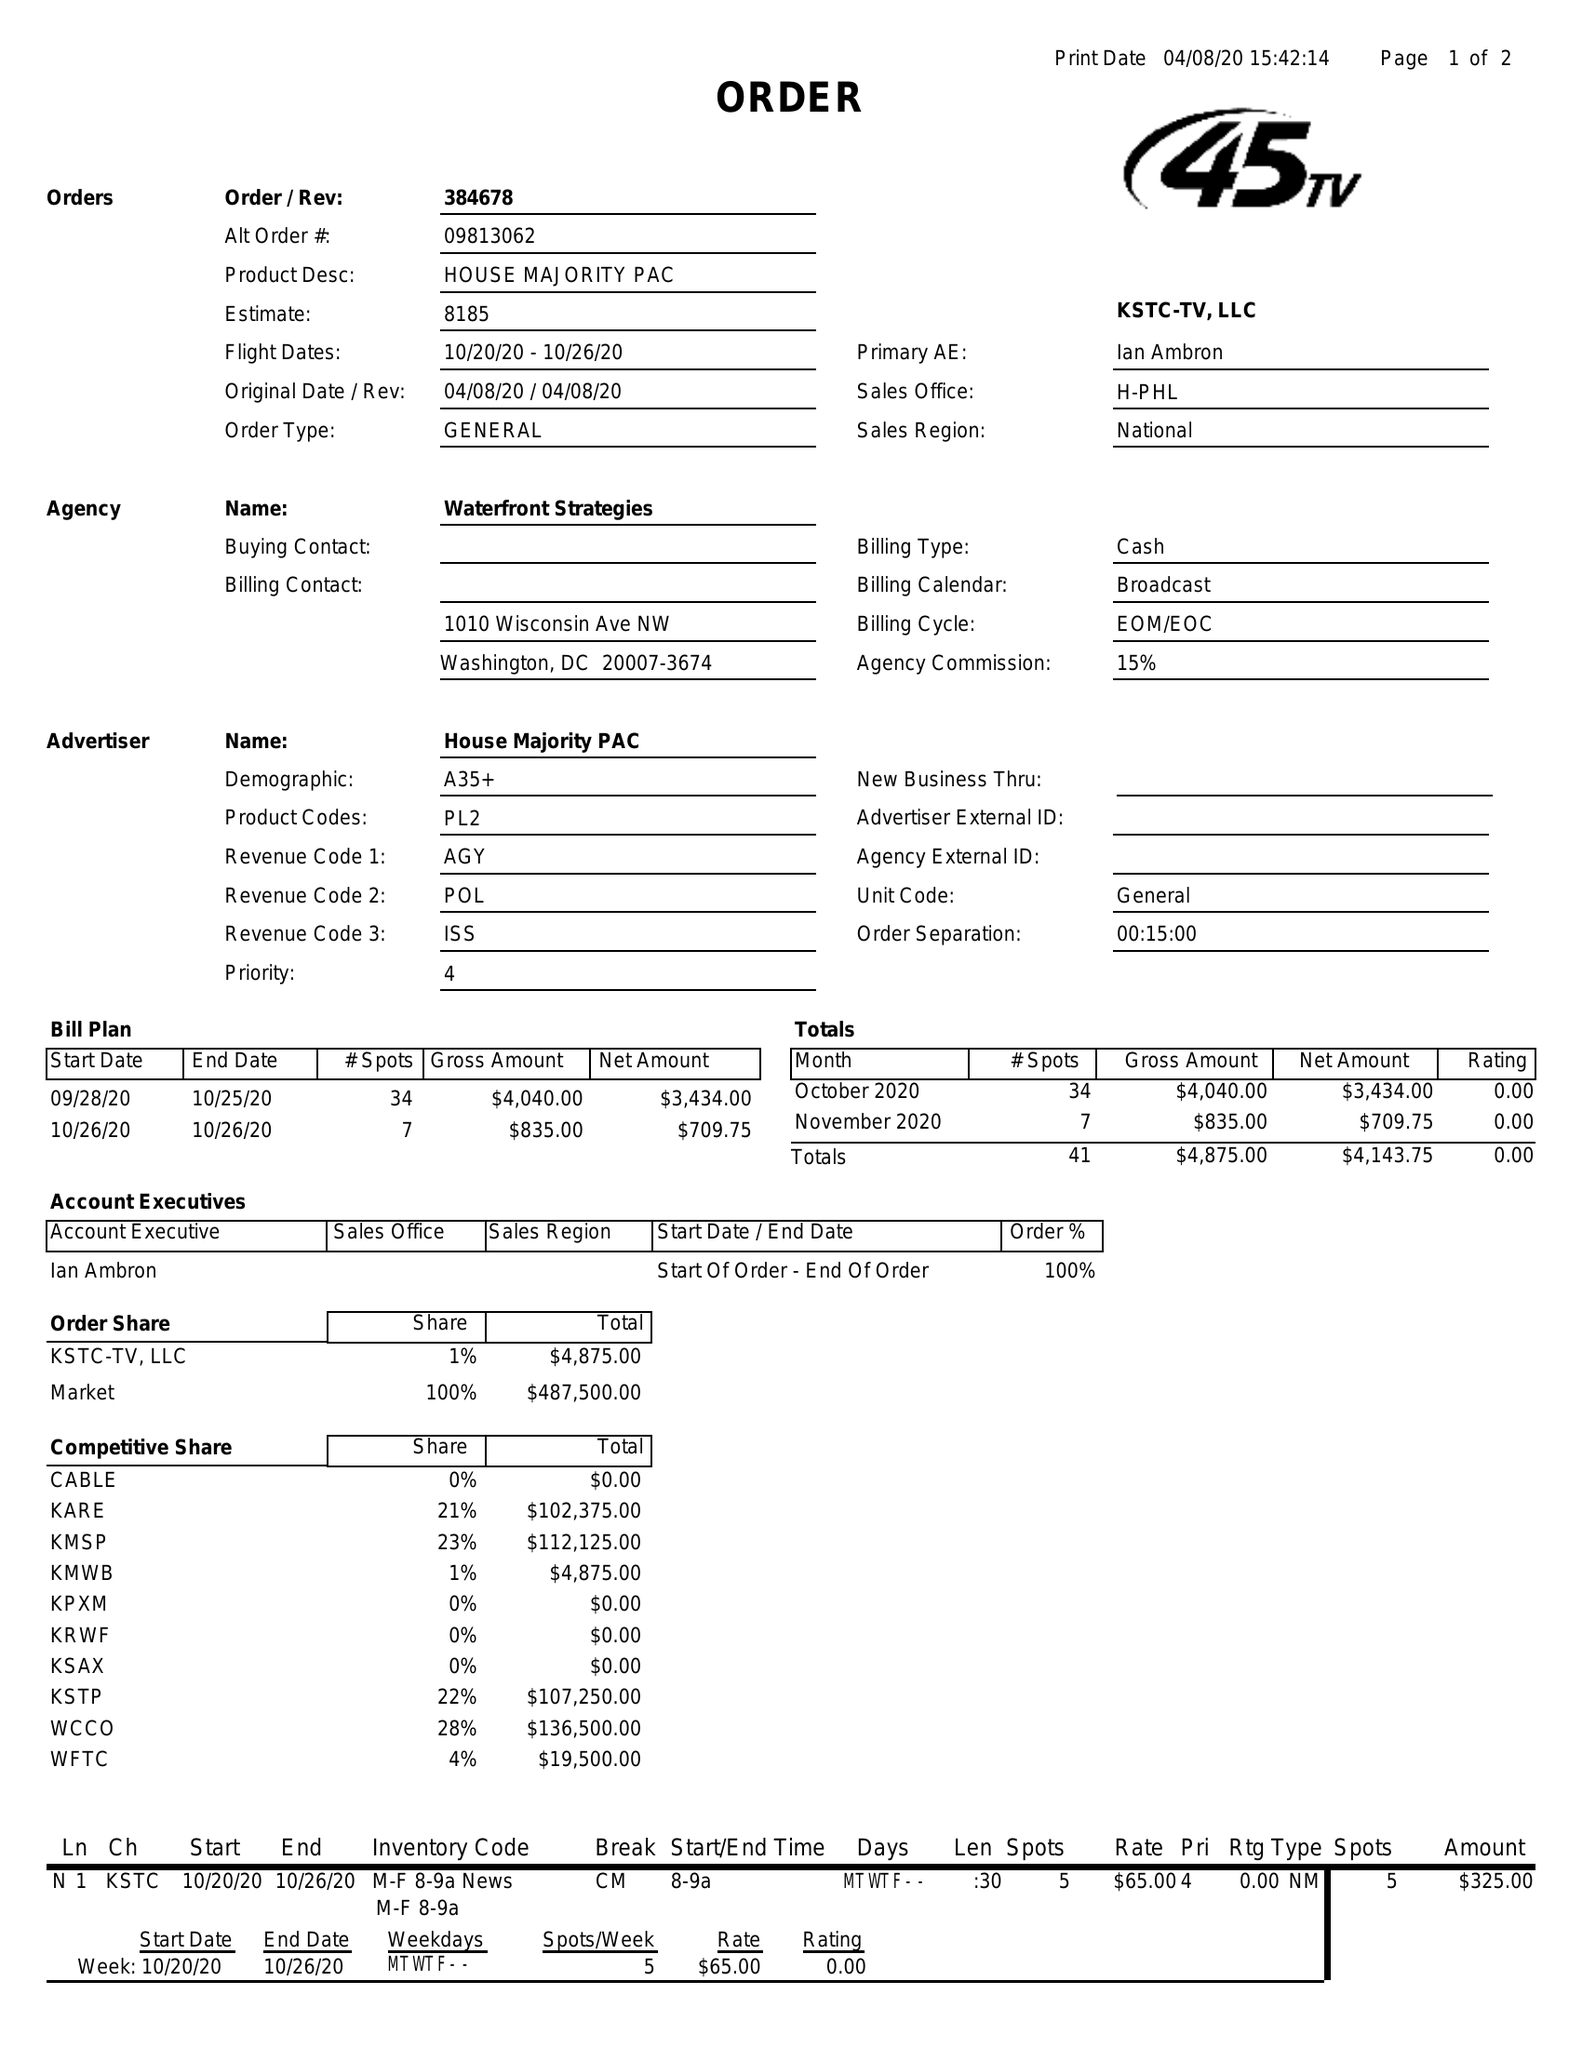What is the value for the flight_from?
Answer the question using a single word or phrase. 10/20/20 